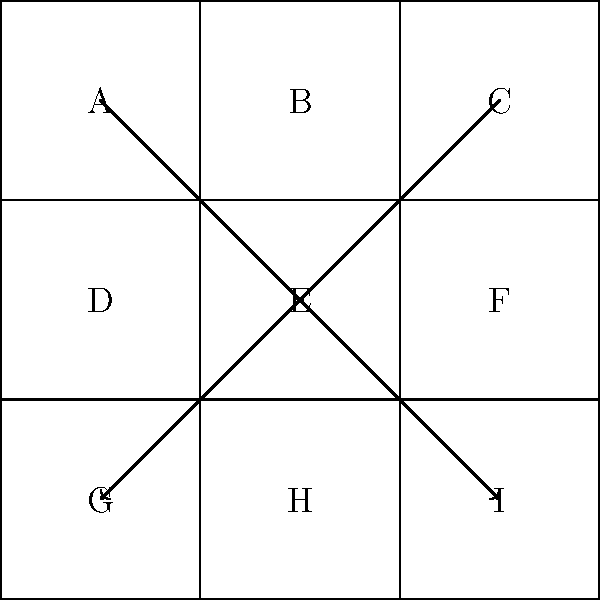In your pixel art RPG game, you've implemented an inventory system with a 3x3 grid. Each slot contains a unique item labeled A through I. Players can rearrange items by swapping their positions. Given the permutation that moves A to I, C to G, and I to A (as shown by the arrows), how many cycles are in this permutation, and what is the order of the permutation group element? Let's approach this step-by-step:

1) First, we need to determine the cycle notation of the given permutation:
   - A goes to I
   - I goes to A
   - C goes to G
   
2) We can write this as: (A I)(C G)
   Note that B, D, E, F, and H are fixed points, so they're not included in any cycle.

3) Counting the cycles:
   - (A I) is one cycle
   - (C G) is another cycle
   - Each fixed point (B, D, E, F, H) is considered a cycle of length 1
   So, there are 2 + 5 = 7 cycles in total.

4) To find the order of this permutation group element, we need to find the least common multiple (LCM) of the lengths of all cycles:
   - (A I) has length 2
   - (C G) has length 2
   - All other cycles have length 1

5) The LCM of 2, 2, and 1 is 2.

Therefore, the permutation has 7 cycles, and its order in the permutation group is 2.
Answer: 7 cycles, order 2 